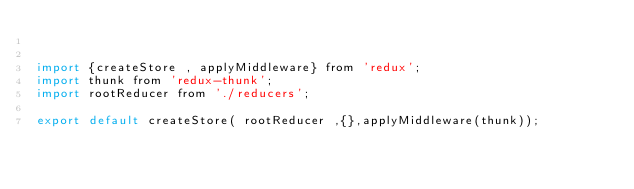Convert code to text. <code><loc_0><loc_0><loc_500><loc_500><_JavaScript_>

import {createStore , applyMiddleware} from 'redux';
import thunk from 'redux-thunk';
import rootReducer from './reducers';

export default createStore( rootReducer ,{},applyMiddleware(thunk));</code> 